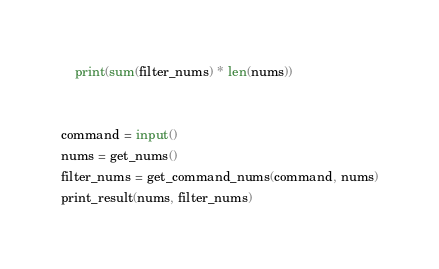Convert code to text. <code><loc_0><loc_0><loc_500><loc_500><_Python_>    print(sum(filter_nums) * len(nums))


command = input()
nums = get_nums()
filter_nums = get_command_nums(command, nums)
print_result(nums, filter_nums)</code> 